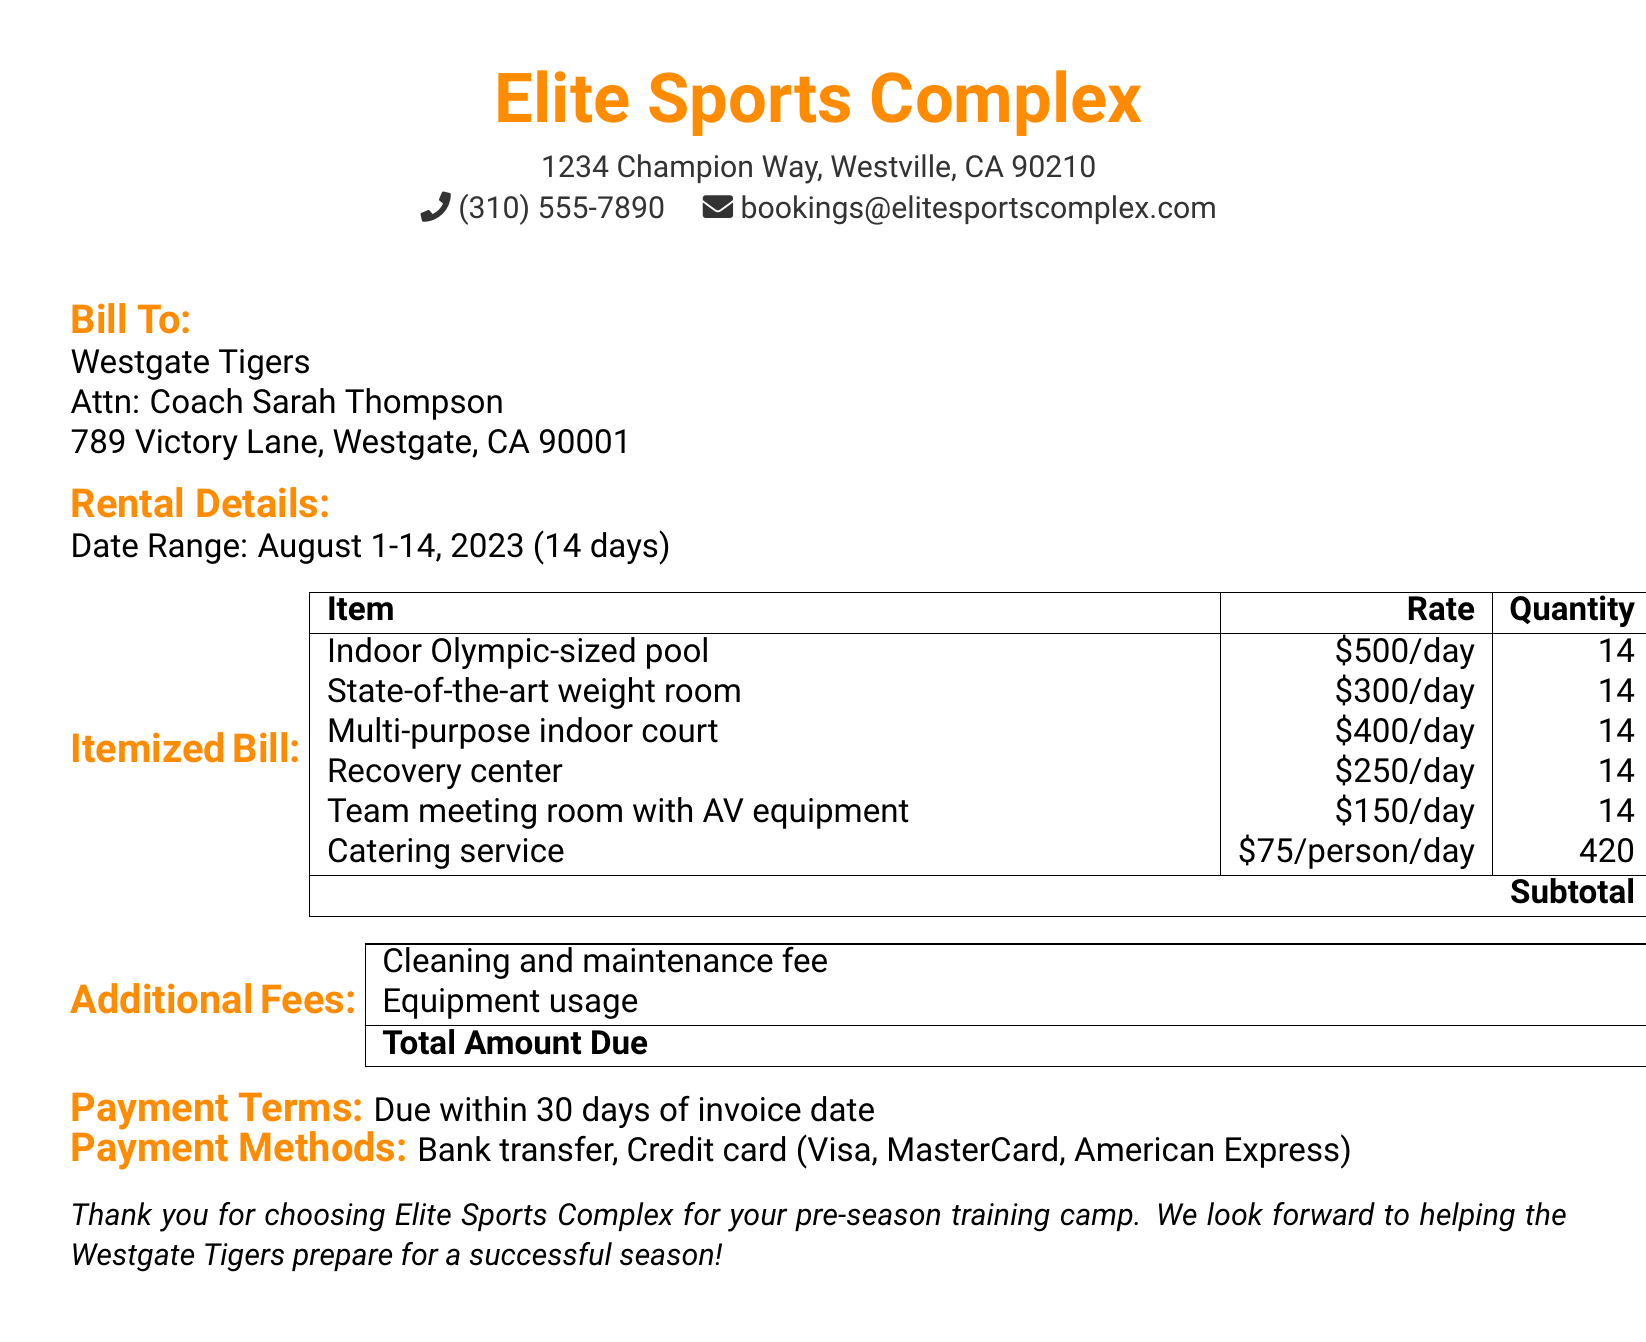What is the total amount due? The total amount due is the final figure noted at the bottom of the bill, which lists all charges including the subtotal and additional fees.
Answer: $56,200 What is the rental period for the sports facility? The rental period is specified in the rental details section, mentioning the start and end dates for the usage of the facilities.
Answer: August 1-14, 2023 How much is the cleaning and maintenance fee? This fee is highlighted in the additional fees section of the document.
Answer: $1,500 How many people are accounted for in the catering service charge? The catering service charge mentions the number of people per day, which can be calculated based on the total quantity during the rental period.
Answer: 420 What is the daily rate for the indoor Olympic-sized pool? The rate is listed next to the item in the itemized bill section, specifying the cost per day for using this facility.
Answer: $500/day What is the subtotal amount before additional fees? The subtotal is provided in the itemized bill as a sum of all the individual charges for the rented items.
Answer: $53,900 How many days does the team plan to use the multi-purpose indoor court? This information can be derived from the rental details, which provides the duration of the rental period applicable to all items listed.
Answer: 14 What payment methods are accepted? The document states options for payment methods clearly listed in the payment terms section.
Answer: Bank transfer, Credit card (Visa, MasterCard, American Express) Who is the bill addressed to? The bill's recipient is specified in the "Bill To" section, indicating the name of the team and the person responsible for it.
Answer: Westgate Tigers, Coach Sarah Thompson 